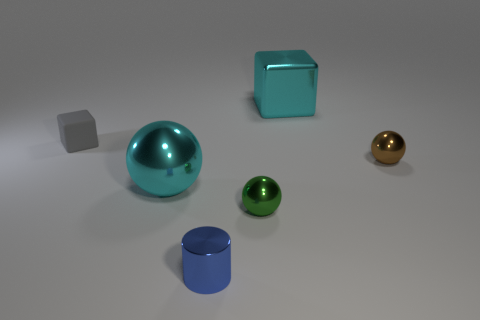Add 2 shiny cubes. How many objects exist? 8 Subtract all cyan balls. How many balls are left? 2 Subtract all brown balls. How many balls are left? 2 Subtract all cubes. How many objects are left? 4 Subtract 2 blocks. How many blocks are left? 0 Subtract all purple cubes. Subtract all yellow cylinders. How many cubes are left? 2 Subtract all cyan cubes. How many cyan cylinders are left? 0 Subtract all tiny yellow metallic things. Subtract all small cylinders. How many objects are left? 5 Add 2 balls. How many balls are left? 5 Add 6 green spheres. How many green spheres exist? 7 